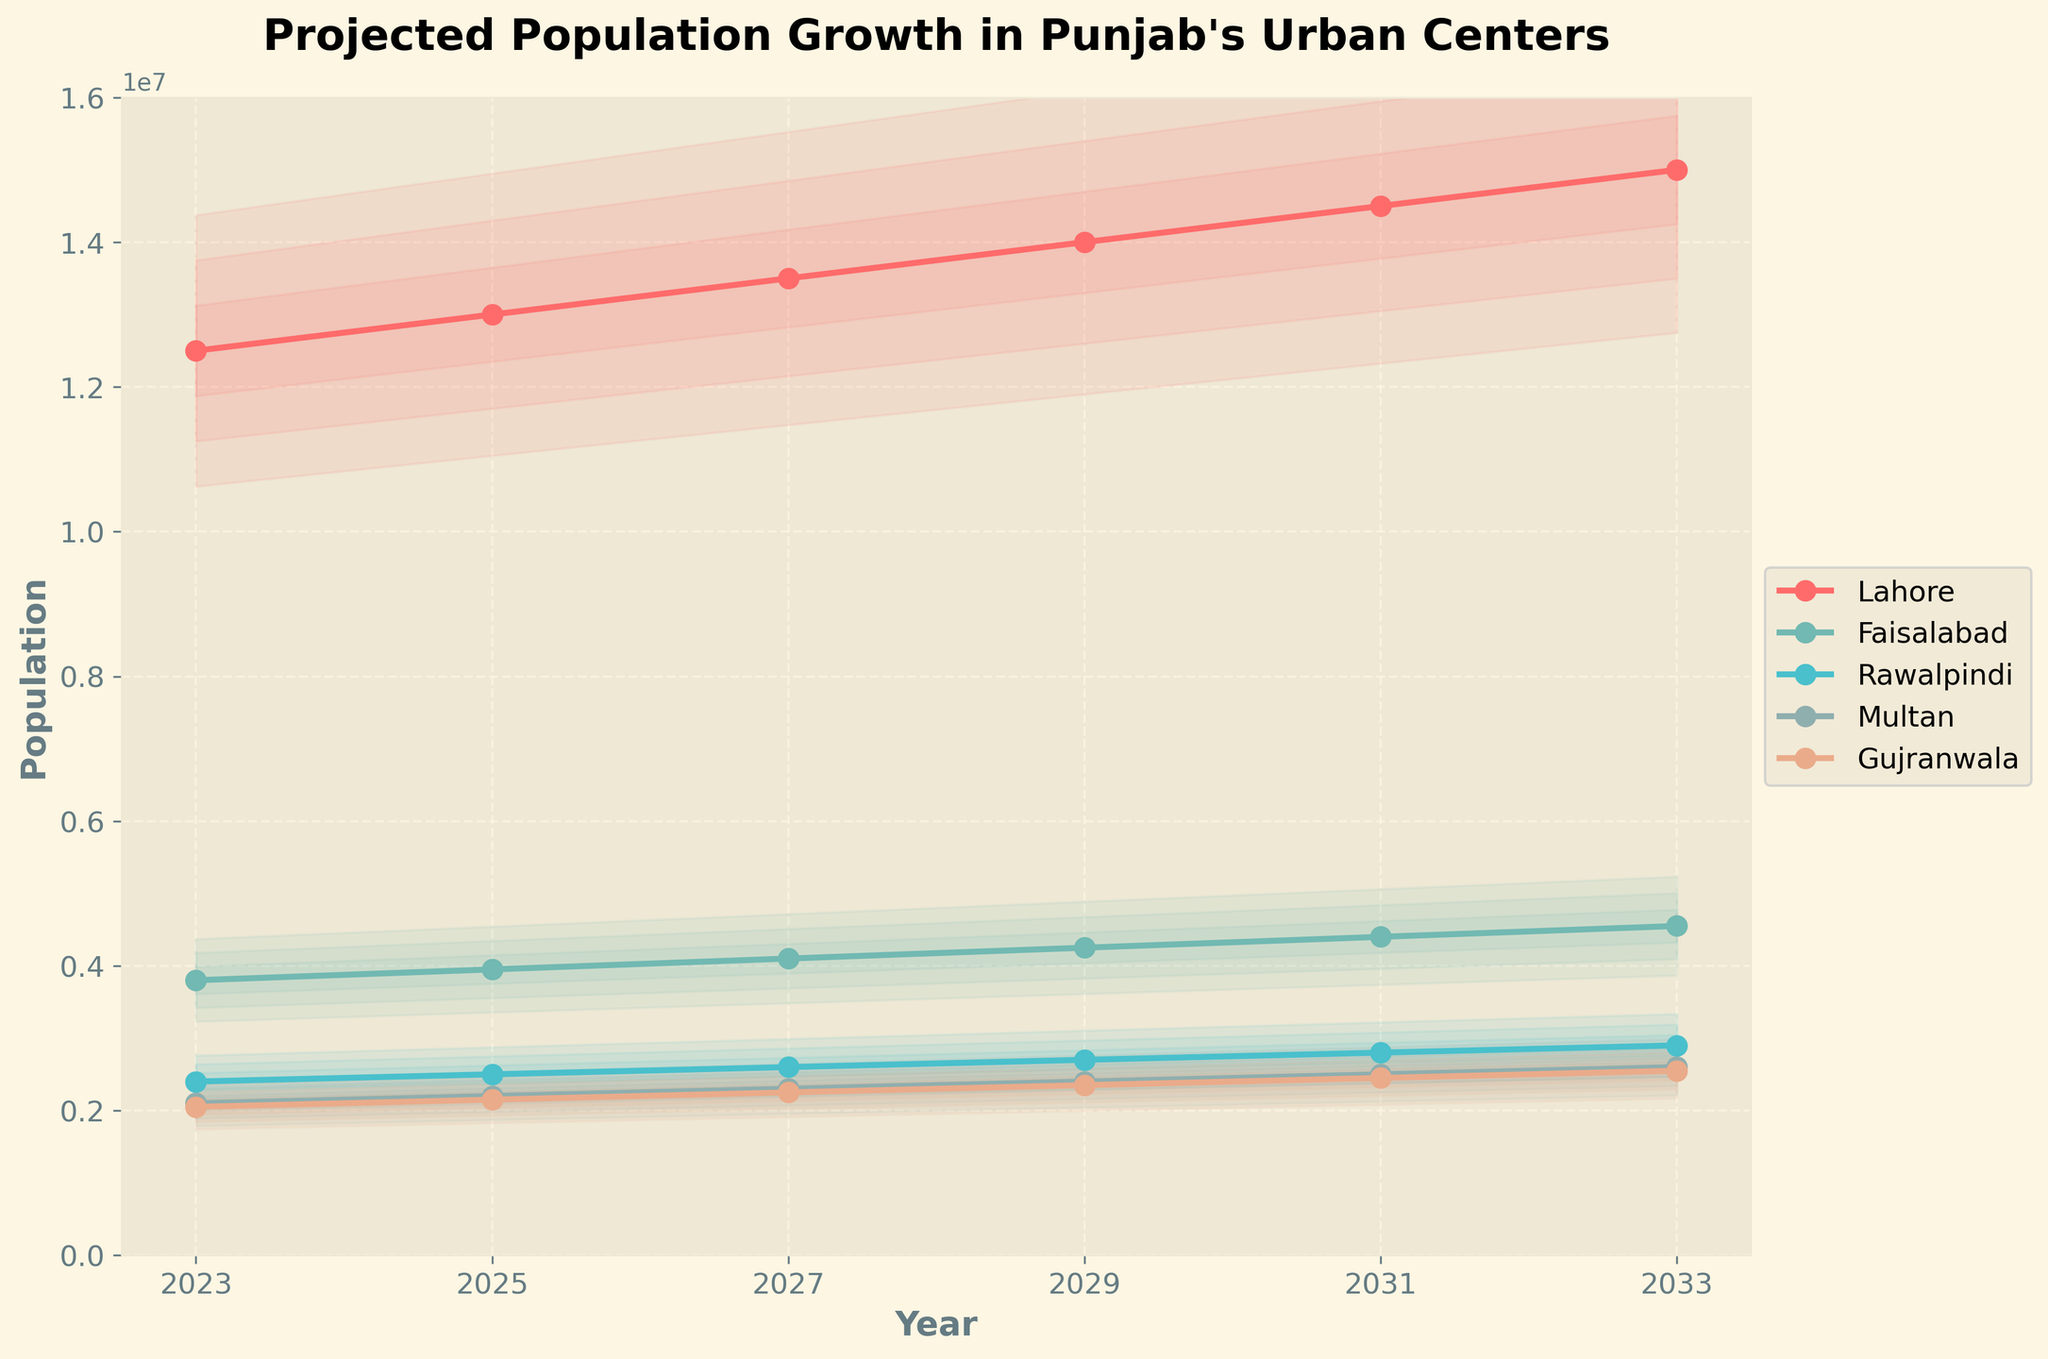What is the title of the chart? The title of the chart is usually placed at the top, and it summarizes the purpose of the chart, which helps viewers understand what data the chart represents.
Answer: Projected Population Growth in Punjab's Urban Centers Which city is projected to have the highest population growth by 2033? To determine the city with the highest population growth, we need to look at the endpoint of each city's line on the chart, which corresponds to the year 2033.
Answer: Lahore How much is the projected population of Faisalabad in 2027? Locate the line representing Faisalabad and follow it to the data point corresponding to the year 2027.
Answer: 4,100,000 Between which years does Lahore see the most significant increase in population? Compare the slopes of the lines for Lahore between each set of years to see which segment has the steepest slope, indicating the most considerable increase in population.
Answer: 2023 to 2025 Which city has the least population in 2023, and what is that population? Look at the starting points of the lines for each city in the year 2023 and identify the one with the lowest value.
Answer: Gujranwala; 2,050,000 How does the population of Multan in 2031 compare to Rawalpindi's in the same year? Find the data points for Multan and Rawalpindi in the year 2031 and compare their values.
Answer: Multan's population is higher What is the average projected population for Gujranwala between 2023 and 2033? Add the projected populations of Gujranwala for each year and divide by the number of years: (2,050,000 + 2,150,000 + 2,250,000 + 2,350,000 + 2,450,000 + 2,550,000) / 6.
Answer: 2,300,000 Which city's population shows the least variation over the time period? The city with the smallest difference between its maximum and minimum projected population values over the time period shows the least variation.
Answer: Rawalpindi How much is the projected increase in population for Multan from 2023 to 2029? Subtract the population value of Multan in 2023 from its value in 2029: 2,400,000 - 2,100,000.
Answer: 300,000 In terms of fan effect, what does the fill between lines for each city represent? The fan effect represents an uncertainty range, filling between lines indicates the potential variability (±5%, ±10%, ±15%) around the projected population values for each city.
Answer: Uncertainty range 